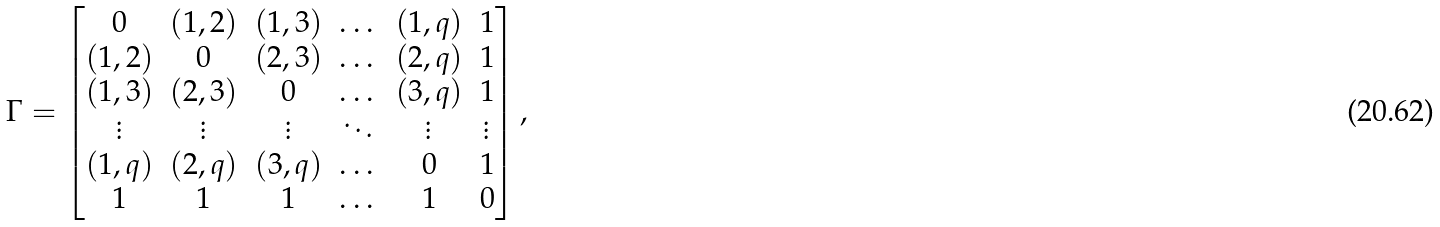Convert formula to latex. <formula><loc_0><loc_0><loc_500><loc_500>\Gamma = \left [ \begin{matrix} 0 & ( 1 , 2 ) & ( 1 , 3 ) & \dots & ( 1 , q ) & 1 \\ ( 1 , 2 ) & 0 & ( 2 , 3 ) & \dots & ( 2 , q ) & 1 \\ ( 1 , 3 ) & ( 2 , 3 ) & 0 & \dots & ( 3 , q ) & 1 \\ \vdots & \vdots & \vdots & \ddots & \vdots & \vdots \\ ( 1 , q ) & ( 2 , q ) & ( 3 , q ) & \dots & 0 & 1 \\ 1 & 1 & 1 & \dots & 1 & 0 \end{matrix} \right ] ,</formula> 